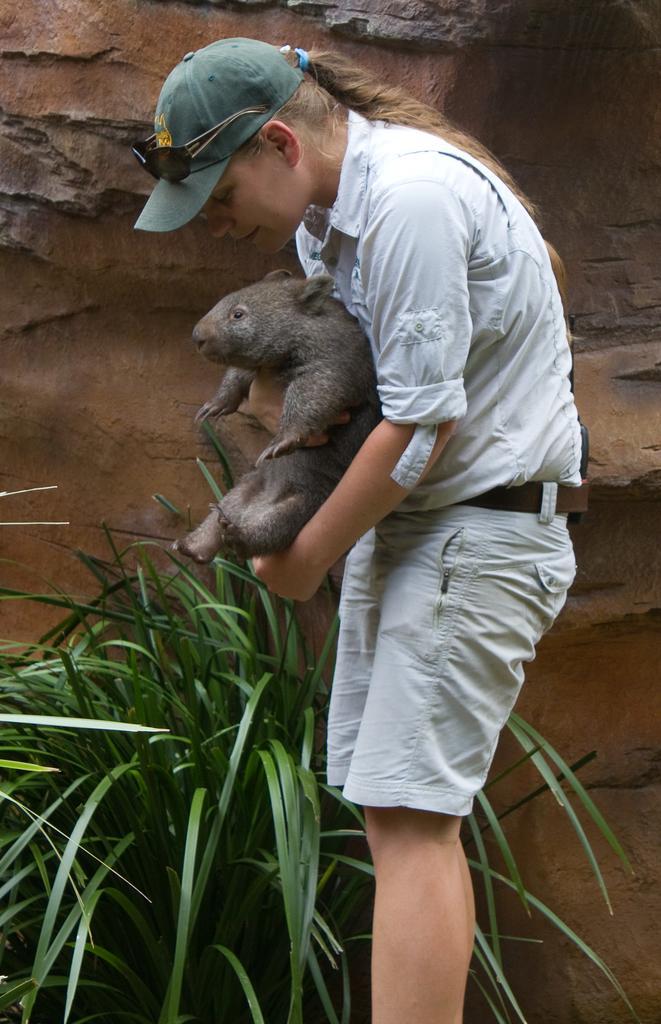Can you describe this image briefly? In the middle of the image a woman is standing and holding a animal. Beside her there is a plant and wall. 